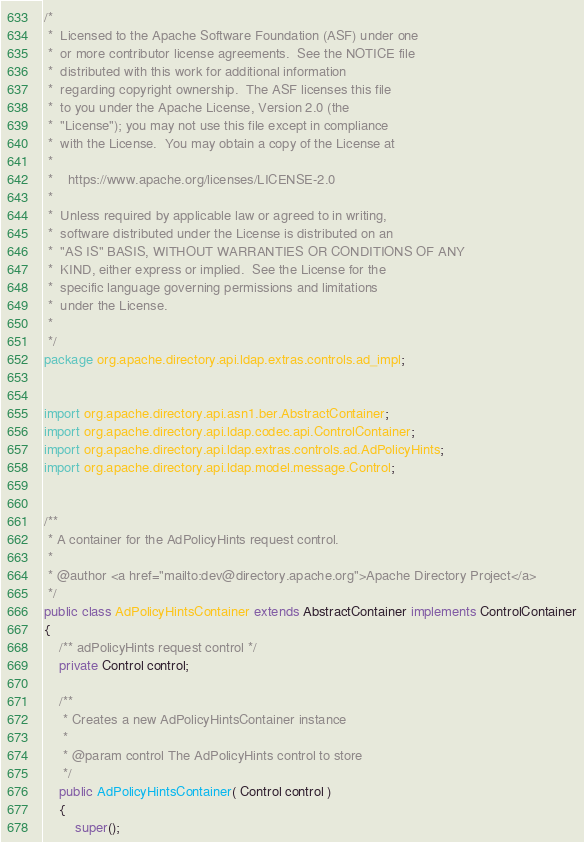<code> <loc_0><loc_0><loc_500><loc_500><_Java_>/*
 *  Licensed to the Apache Software Foundation (ASF) under one
 *  or more contributor license agreements.  See the NOTICE file
 *  distributed with this work for additional information
 *  regarding copyright ownership.  The ASF licenses this file
 *  to you under the Apache License, Version 2.0 (the
 *  "License"); you may not use this file except in compliance
 *  with the License.  You may obtain a copy of the License at
 *
 *    https://www.apache.org/licenses/LICENSE-2.0
 *
 *  Unless required by applicable law or agreed to in writing,
 *  software distributed under the License is distributed on an
 *  "AS IS" BASIS, WITHOUT WARRANTIES OR CONDITIONS OF ANY
 *  KIND, either express or implied.  See the License for the
 *  specific language governing permissions and limitations
 *  under the License.
 *
 */
package org.apache.directory.api.ldap.extras.controls.ad_impl;


import org.apache.directory.api.asn1.ber.AbstractContainer;
import org.apache.directory.api.ldap.codec.api.ControlContainer;
import org.apache.directory.api.ldap.extras.controls.ad.AdPolicyHints;
import org.apache.directory.api.ldap.model.message.Control;


/**
 * A container for the AdPolicyHints request control.
 * 
 * @author <a href="mailto:dev@directory.apache.org">Apache Directory Project</a>
 */
public class AdPolicyHintsContainer extends AbstractContainer implements ControlContainer
{
    /** adPolicyHints request control */
    private Control control;

    /**
     * Creates a new AdPolicyHintsContainer instance
     *
     * @param control The AdPolicyHints control to store
     */
    public AdPolicyHintsContainer( Control control )
    {
        super();</code> 